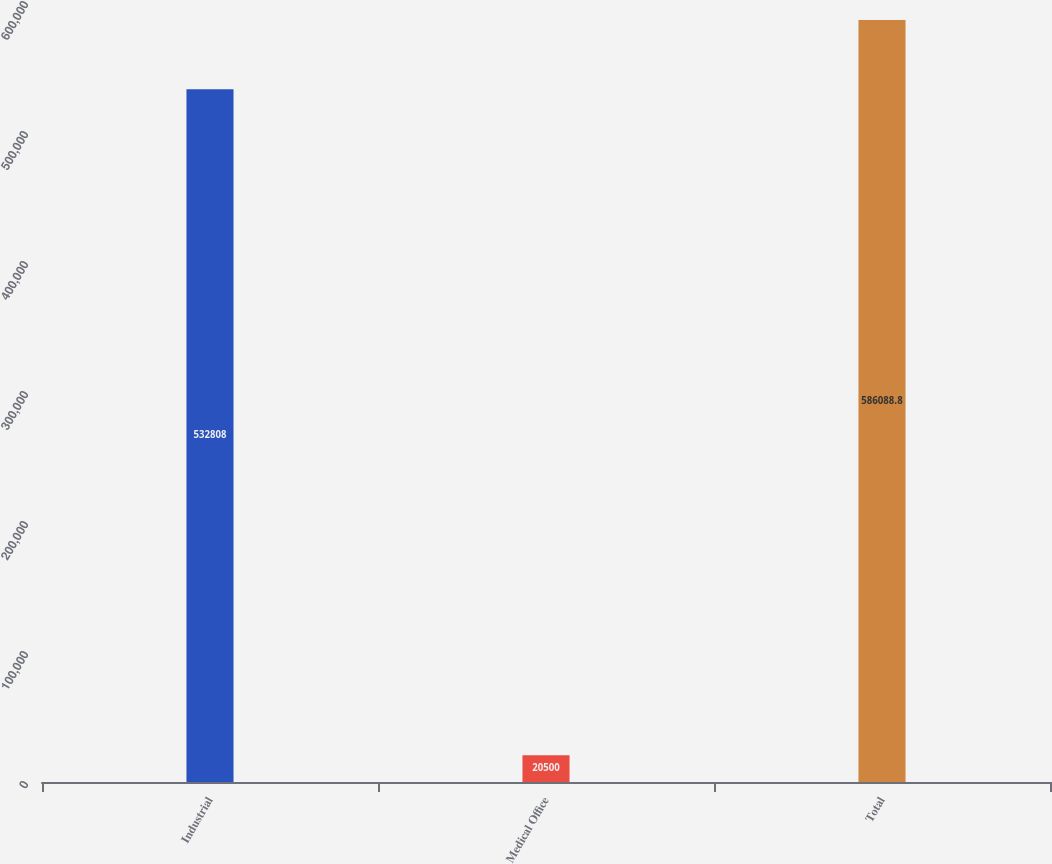Convert chart. <chart><loc_0><loc_0><loc_500><loc_500><bar_chart><fcel>Industrial<fcel>Medical Office<fcel>Total<nl><fcel>532808<fcel>20500<fcel>586089<nl></chart> 